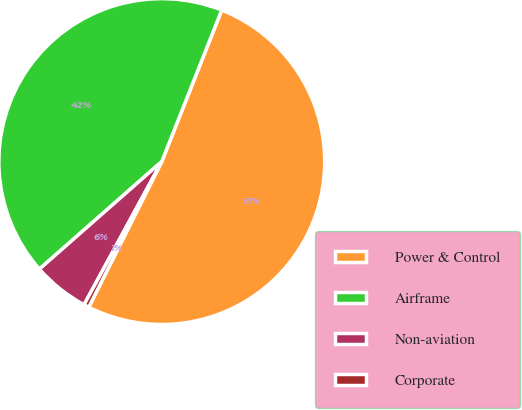Convert chart to OTSL. <chart><loc_0><loc_0><loc_500><loc_500><pie_chart><fcel>Power & Control<fcel>Airframe<fcel>Non-aviation<fcel>Corporate<nl><fcel>51.4%<fcel>42.47%<fcel>5.61%<fcel>0.52%<nl></chart> 